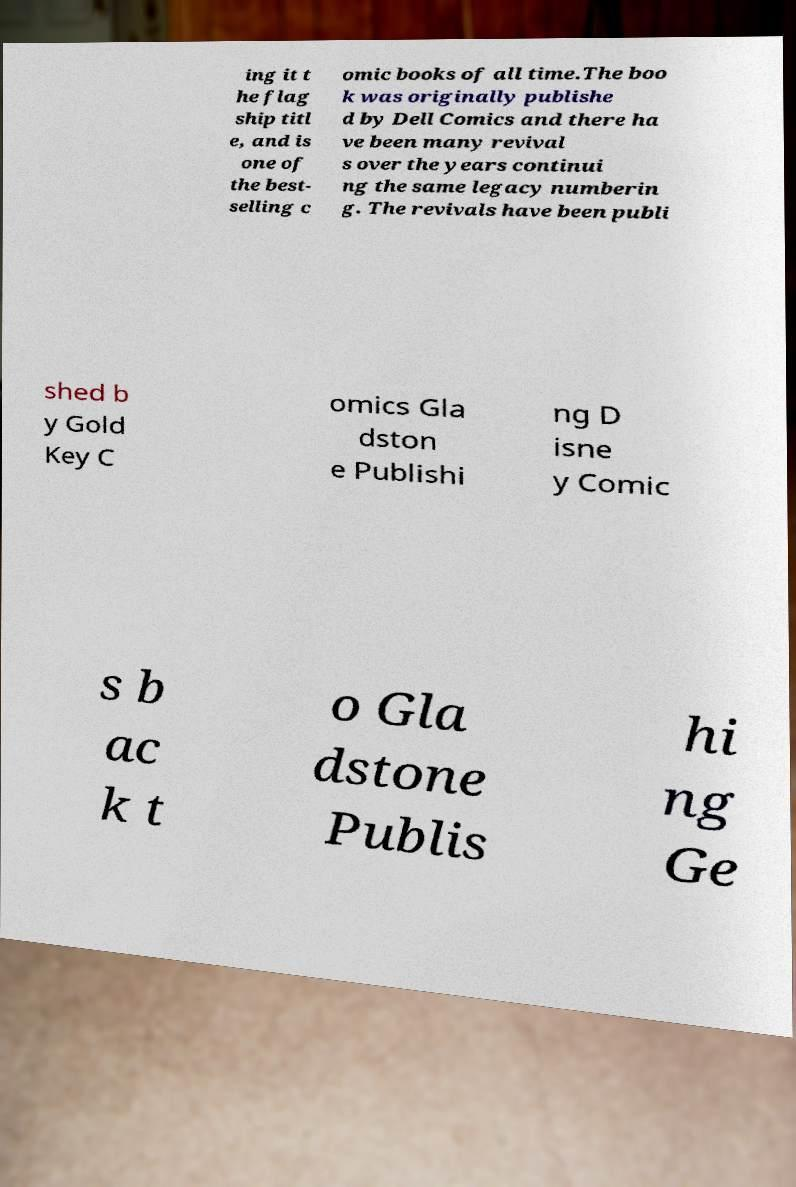There's text embedded in this image that I need extracted. Can you transcribe it verbatim? ing it t he flag ship titl e, and is one of the best- selling c omic books of all time.The boo k was originally publishe d by Dell Comics and there ha ve been many revival s over the years continui ng the same legacy numberin g. The revivals have been publi shed b y Gold Key C omics Gla dston e Publishi ng D isne y Comic s b ac k t o Gla dstone Publis hi ng Ge 